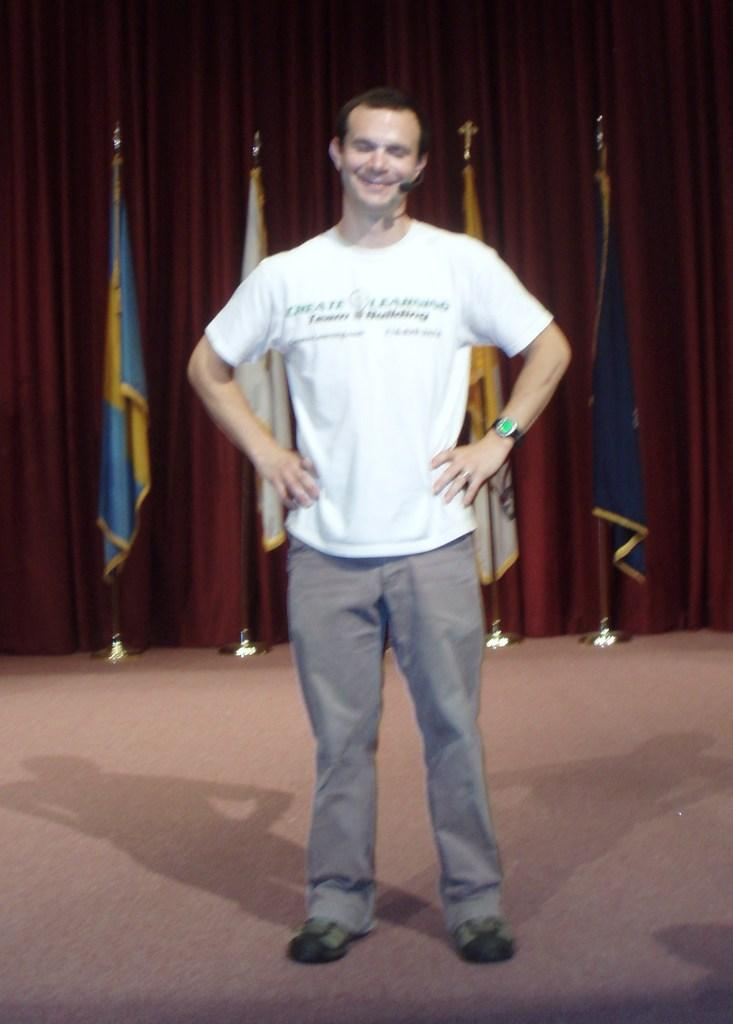What is the main subject of the image? There is a person standing in the image. Can you describe the person's attire? The person is wearing a white and ash color dress. What can be seen in the background of the image? There are many flags and a maroon color curtain in the background of the image. What type of paste is being used by the person in the image? There is no paste visible in the image, and the person's actions are not described. 